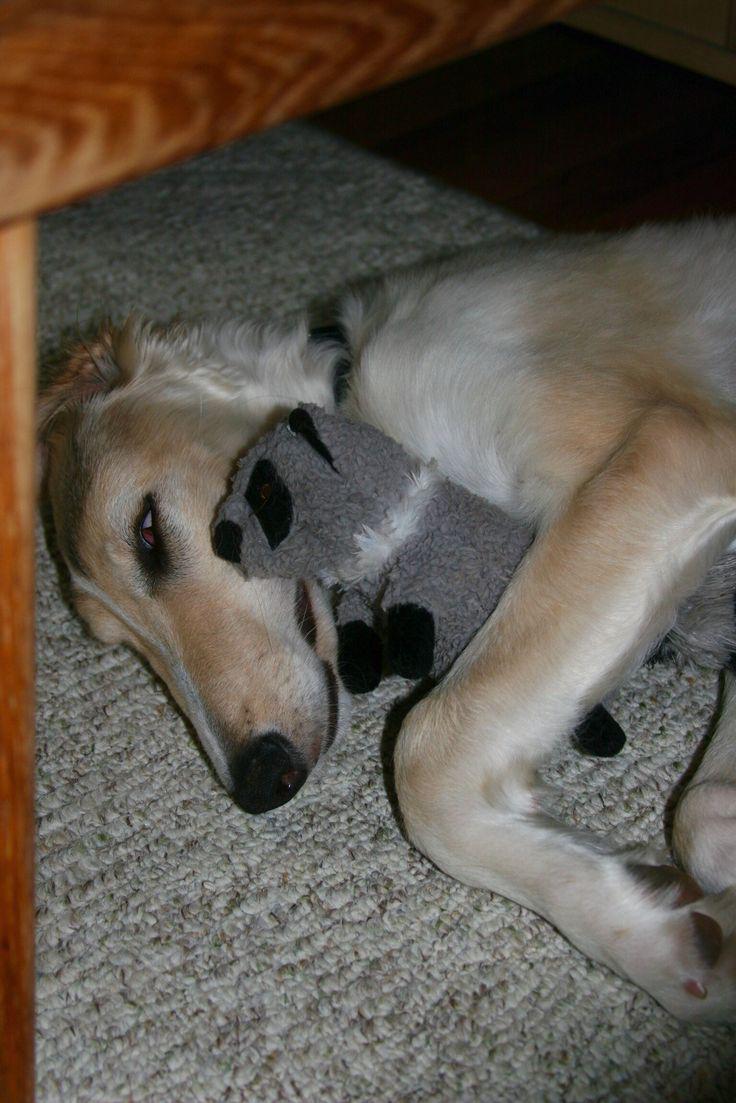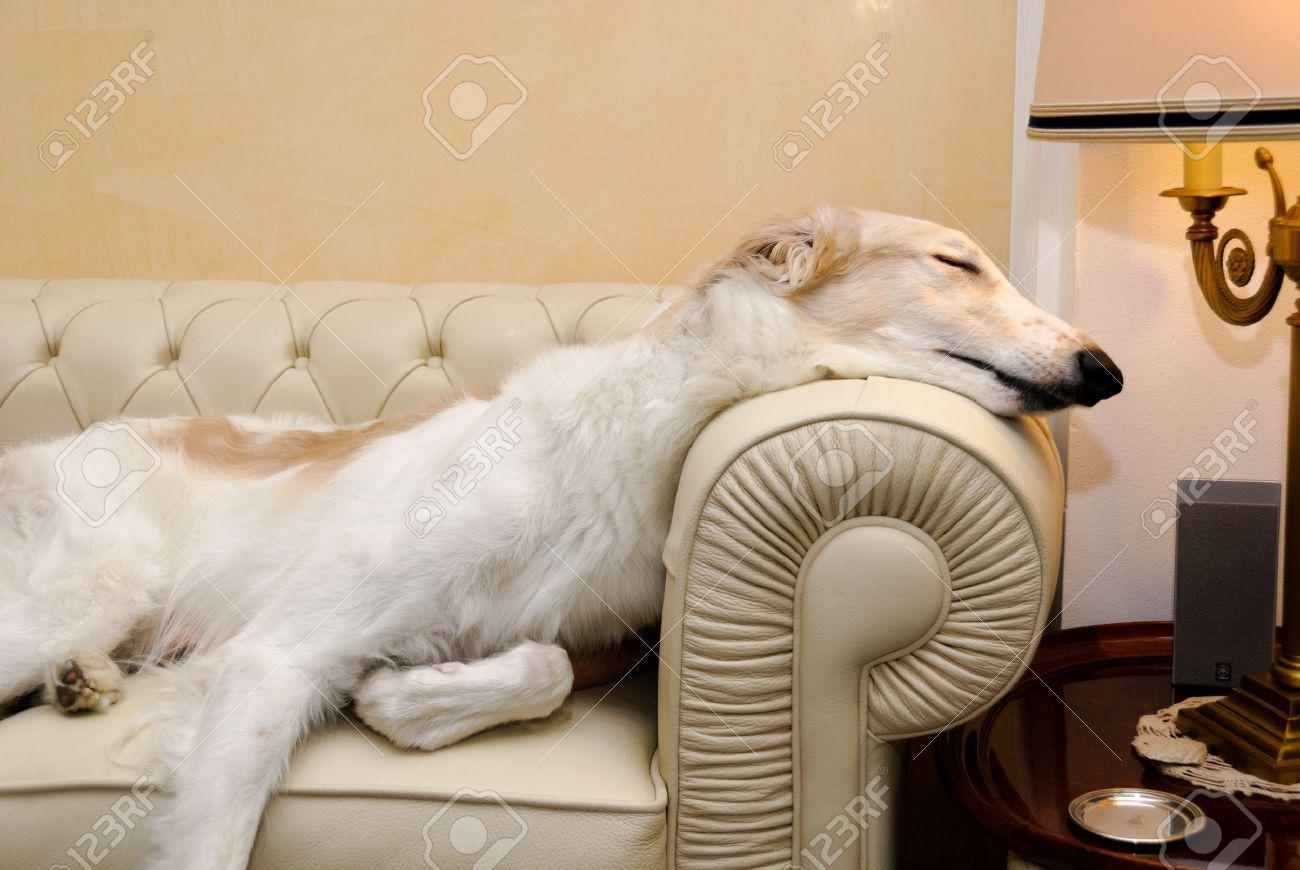The first image is the image on the left, the second image is the image on the right. Assess this claim about the two images: "The dog in the image on the right is lying on a couch.". Correct or not? Answer yes or no. Yes. The first image is the image on the left, the second image is the image on the right. Given the left and right images, does the statement "A dog is lying on the floor on a rug." hold true? Answer yes or no. Yes. 